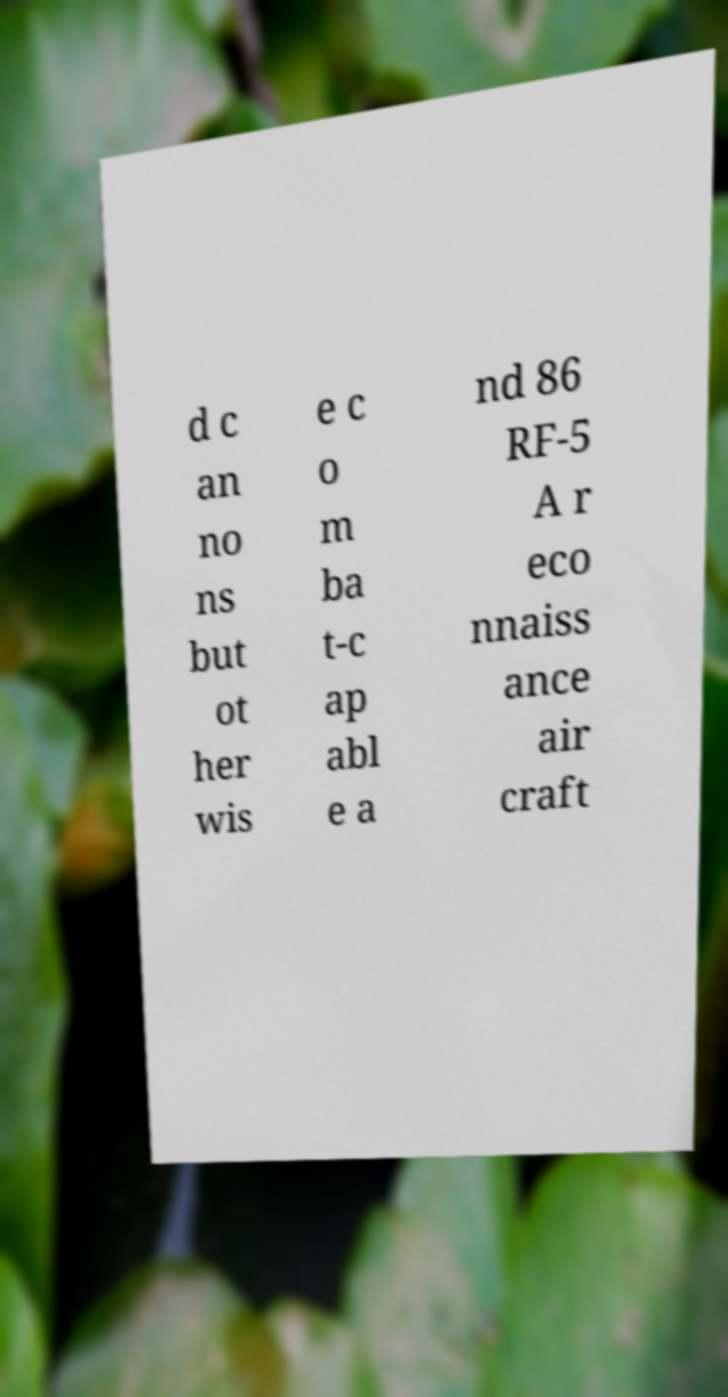What messages or text are displayed in this image? I need them in a readable, typed format. d c an no ns but ot her wis e c o m ba t-c ap abl e a nd 86 RF-5 A r eco nnaiss ance air craft 